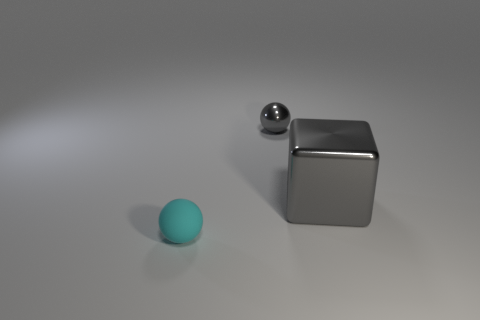Add 2 gray balls. How many objects exist? 5 Subtract all balls. How many objects are left? 1 Add 3 big red rubber things. How many big red rubber things exist? 3 Subtract 0 blue cubes. How many objects are left? 3 Subtract all cyan matte spheres. Subtract all small metal things. How many objects are left? 1 Add 1 small gray objects. How many small gray objects are left? 2 